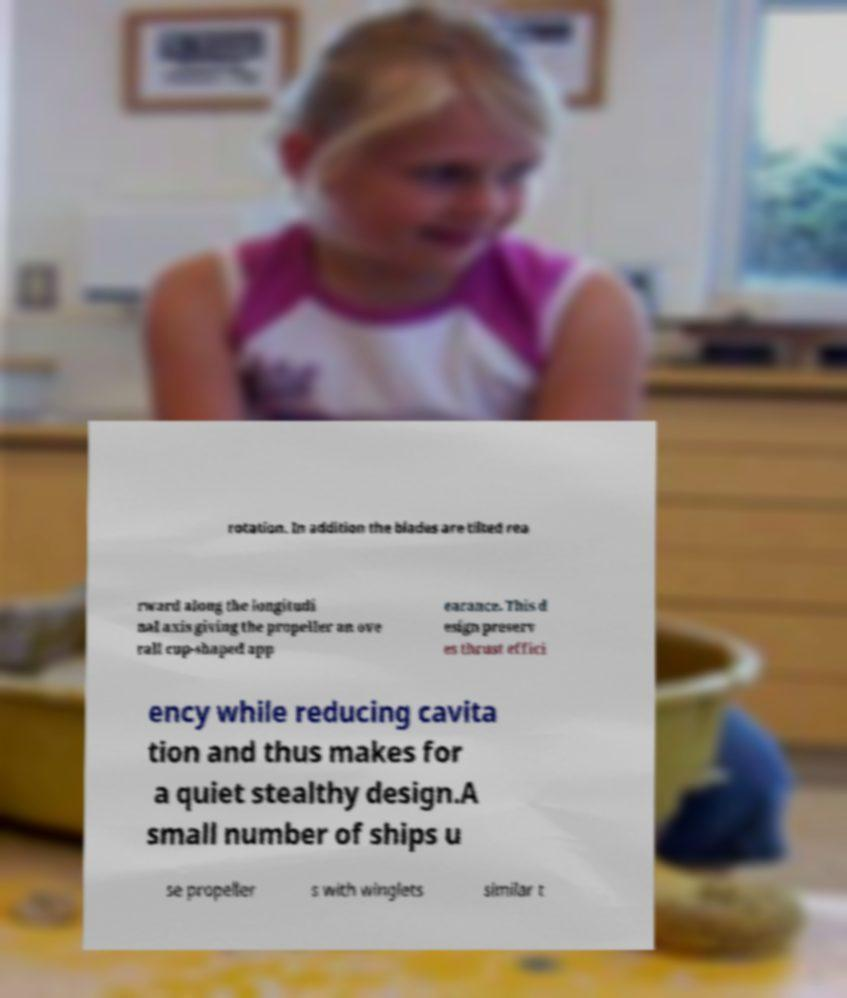For documentation purposes, I need the text within this image transcribed. Could you provide that? rotation. In addition the blades are tilted rea rward along the longitudi nal axis giving the propeller an ove rall cup-shaped app earance. This d esign preserv es thrust effici ency while reducing cavita tion and thus makes for a quiet stealthy design.A small number of ships u se propeller s with winglets similar t 